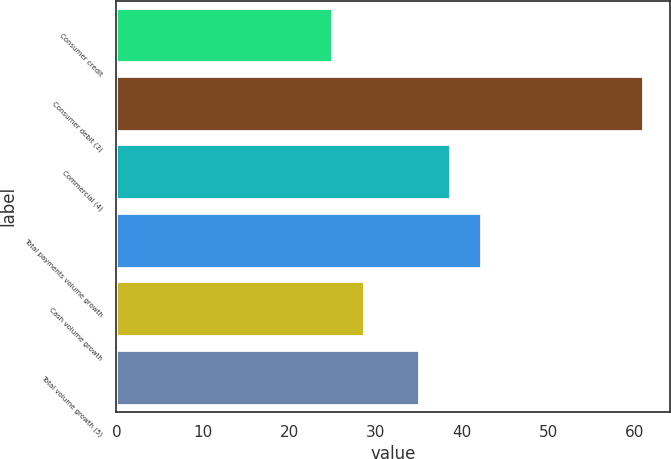<chart> <loc_0><loc_0><loc_500><loc_500><bar_chart><fcel>Consumer credit<fcel>Consumer debit (3)<fcel>Commercial (4)<fcel>Total payments volume growth<fcel>Cash volume growth<fcel>Total volume growth (5)<nl><fcel>25<fcel>61<fcel>38.6<fcel>42.2<fcel>28.6<fcel>35<nl></chart> 